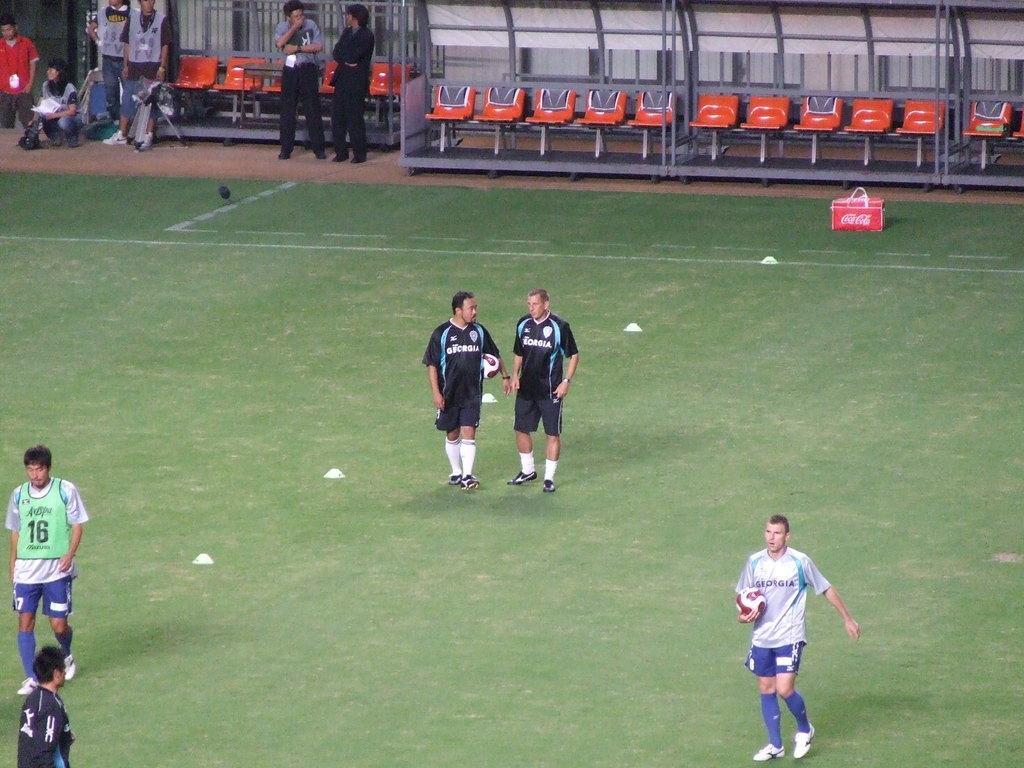How would you summarize this image in a sentence or two? Here we can see a ground and in this ground there are football players and at the right side we can see a player holding a football and at the top we can see chairs present and some people are standing 